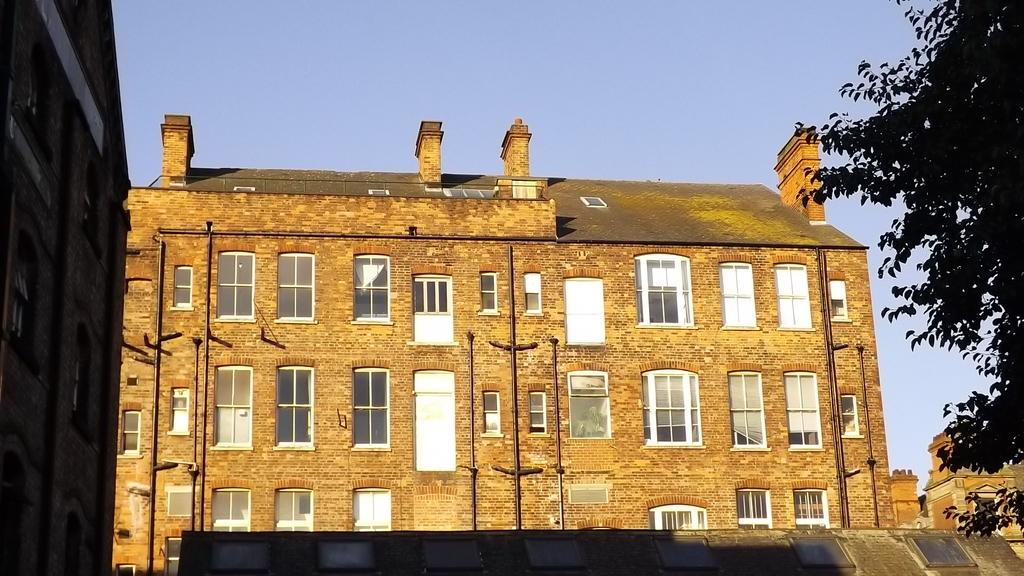What type of structures are present in the image? There are buildings with windows in the image. What feature do the buildings have? The buildings have glass doors. Can you describe the object located at the bottom side of the image? Unfortunately, the facts provided do not give enough information about the object at the bottom side of the image. What type of vegetation can be seen in the image? There is a tree visible in the image. What part of the natural environment is visible in the image? The sky is visible in the image. What type of meat is being sold at the cemetery in the image? There is no mention of a cemetery or meat in the image. The image features buildings with windows, glass doors, a tree, and the sky. 